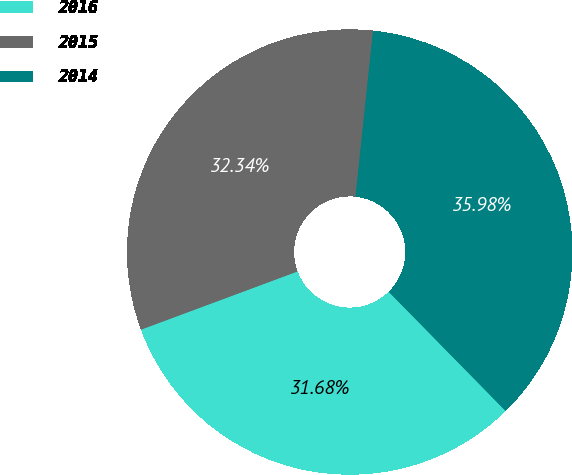Convert chart to OTSL. <chart><loc_0><loc_0><loc_500><loc_500><pie_chart><fcel>2016<fcel>2015<fcel>2014<nl><fcel>31.68%<fcel>32.34%<fcel>35.98%<nl></chart> 